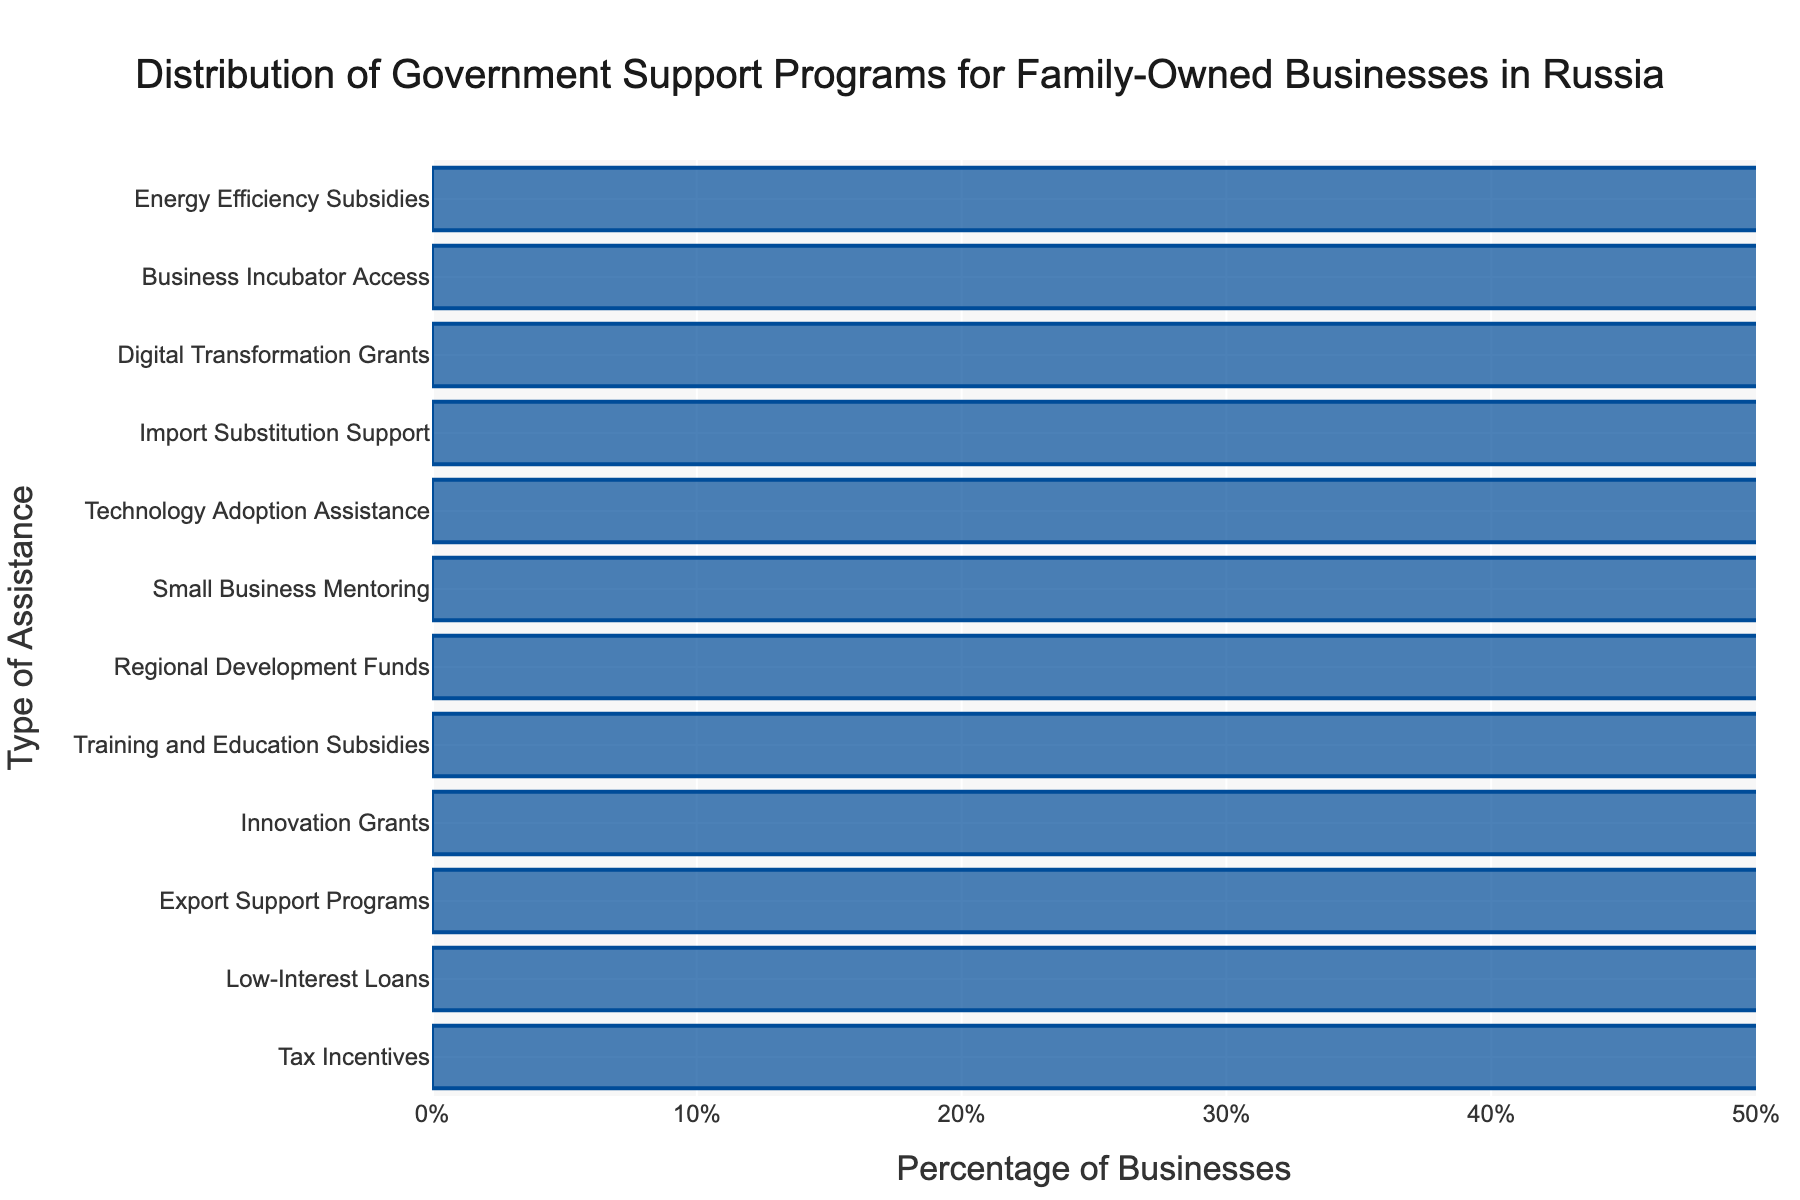How many more businesses utilize Tax Incentives compared to Business Incubator Access? To determine this, look at the percentages of businesses using each type of assistance. Tax Incentives are at 42% while Business Incubator Access is at 5%. Subtract 5 from 42 to find the difference.
Answer: 37% Which assistance type is utilized by fewer businesses, Regional Development Funds or Import Substitution Support? Compare the percentages of businesses for both types. Regional Development Funds are at 15%, while Import Substitution Support is at 8%. Since 8% is less than 15%, Import Substitution Support is utilized by fewer businesses.
Answer: Import Substitution Support What is the combined percentage of businesses utilizing Export Support Programs and Innovation Grants? To find the combined percentage, add the percentages of businesses using each type of assistance. Export Support Programs are at 27%, and Innovation Grants are at 23%. Therefore, 27 + 23 equals 50.
Answer: 50% Is Low-Interest Loans more popular than Digital Transformation Grants, and by how much? Compare the percentages of businesses for each type of assistance. Low-Interest Loans are at 38%, while Digital Transformation Grants are at 7%. Subtract 7 from 38 to find the difference.
Answer: 31% What is the median percentage value of the assistance types shown? To find the median, sort all the percentages in ascending order and locate the middle value. The sorted percentages are 4, 5, 7, 8, 10, 12, 15, 19, 23, 27, 38, and 42. The middle values are 15 and 19. The median is the average of these two values: (15 + 19) / 2 = 17.
Answer: 17% Which assistance type has the smallest percentage of businesses utilizing it? Look for the assistance type with the smallest bar, which corresponds to the smallest percentage. Energy Efficiency Subsidies are at the lowest percentage of 4%.
Answer: Energy Efficiency Subsidies What is the difference in percentage between Training and Education Subsidies and Technology Adoption Assistance? Compare the percentages of businesses for each type. Training and Education Subsidies are at 19%, while Technology Adoption Assistance is at 10%. Subtract 10 from 19 to find the difference.
Answer: 9% How much percentage does Small Business Mentoring and Business Incubator Access together cover? Add the percentages of businesses for each type. Small Business Mentoring is at 12% and Business Incubator Access is at 5%. Therefore, 12 + 5 equals 17%.
Answer: 17% What is the range of percentages for the assistance types? The range is determined by subtracting the smallest percentage from the largest percentage. The largest percentage is 42% for Tax Incentives, and the smallest is 4% for Energy Efficiency Subsidies. Subtract 4 from 42 to get the range.
Answer: 38% Which assistance type is slightly less popular than Small Business Mentoring? Examine the bars and find the one immediately less than the 12% for Small Business Mentoring. Technology Adoption Assistance, at 10%, is slightly less popular.
Answer: Technology Adoption Assistance 